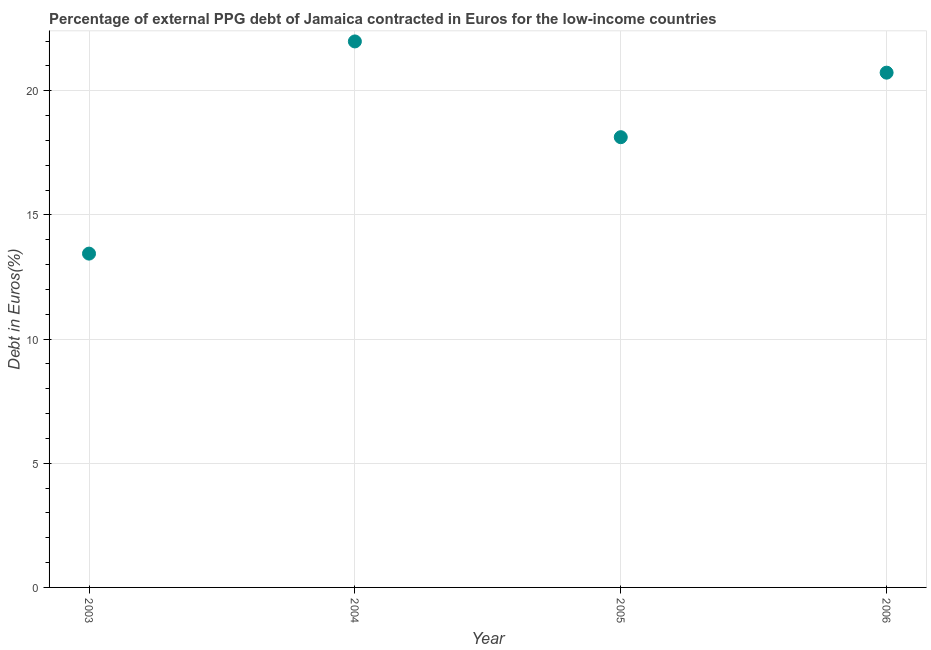What is the currency composition of ppg debt in 2005?
Offer a terse response. 18.13. Across all years, what is the maximum currency composition of ppg debt?
Your answer should be compact. 21.98. Across all years, what is the minimum currency composition of ppg debt?
Your answer should be very brief. 13.44. In which year was the currency composition of ppg debt minimum?
Provide a succinct answer. 2003. What is the sum of the currency composition of ppg debt?
Your response must be concise. 74.28. What is the difference between the currency composition of ppg debt in 2003 and 2005?
Provide a succinct answer. -4.69. What is the average currency composition of ppg debt per year?
Offer a terse response. 18.57. What is the median currency composition of ppg debt?
Ensure brevity in your answer.  19.43. In how many years, is the currency composition of ppg debt greater than 5 %?
Your answer should be compact. 4. Do a majority of the years between 2006 and 2005 (inclusive) have currency composition of ppg debt greater than 3 %?
Give a very brief answer. No. What is the ratio of the currency composition of ppg debt in 2004 to that in 2005?
Make the answer very short. 1.21. Is the difference between the currency composition of ppg debt in 2005 and 2006 greater than the difference between any two years?
Provide a short and direct response. No. What is the difference between the highest and the second highest currency composition of ppg debt?
Provide a succinct answer. 1.26. What is the difference between the highest and the lowest currency composition of ppg debt?
Your answer should be very brief. 8.54. In how many years, is the currency composition of ppg debt greater than the average currency composition of ppg debt taken over all years?
Give a very brief answer. 2. How many dotlines are there?
Offer a very short reply. 1. What is the difference between two consecutive major ticks on the Y-axis?
Your answer should be very brief. 5. What is the title of the graph?
Your answer should be very brief. Percentage of external PPG debt of Jamaica contracted in Euros for the low-income countries. What is the label or title of the Y-axis?
Give a very brief answer. Debt in Euros(%). What is the Debt in Euros(%) in 2003?
Offer a terse response. 13.44. What is the Debt in Euros(%) in 2004?
Offer a terse response. 21.98. What is the Debt in Euros(%) in 2005?
Keep it short and to the point. 18.13. What is the Debt in Euros(%) in 2006?
Give a very brief answer. 20.73. What is the difference between the Debt in Euros(%) in 2003 and 2004?
Offer a terse response. -8.54. What is the difference between the Debt in Euros(%) in 2003 and 2005?
Offer a terse response. -4.69. What is the difference between the Debt in Euros(%) in 2003 and 2006?
Offer a terse response. -7.29. What is the difference between the Debt in Euros(%) in 2004 and 2005?
Ensure brevity in your answer.  3.86. What is the difference between the Debt in Euros(%) in 2004 and 2006?
Offer a terse response. 1.26. What is the difference between the Debt in Euros(%) in 2005 and 2006?
Provide a succinct answer. -2.6. What is the ratio of the Debt in Euros(%) in 2003 to that in 2004?
Ensure brevity in your answer.  0.61. What is the ratio of the Debt in Euros(%) in 2003 to that in 2005?
Provide a short and direct response. 0.74. What is the ratio of the Debt in Euros(%) in 2003 to that in 2006?
Your response must be concise. 0.65. What is the ratio of the Debt in Euros(%) in 2004 to that in 2005?
Give a very brief answer. 1.21. What is the ratio of the Debt in Euros(%) in 2004 to that in 2006?
Your answer should be compact. 1.06. 